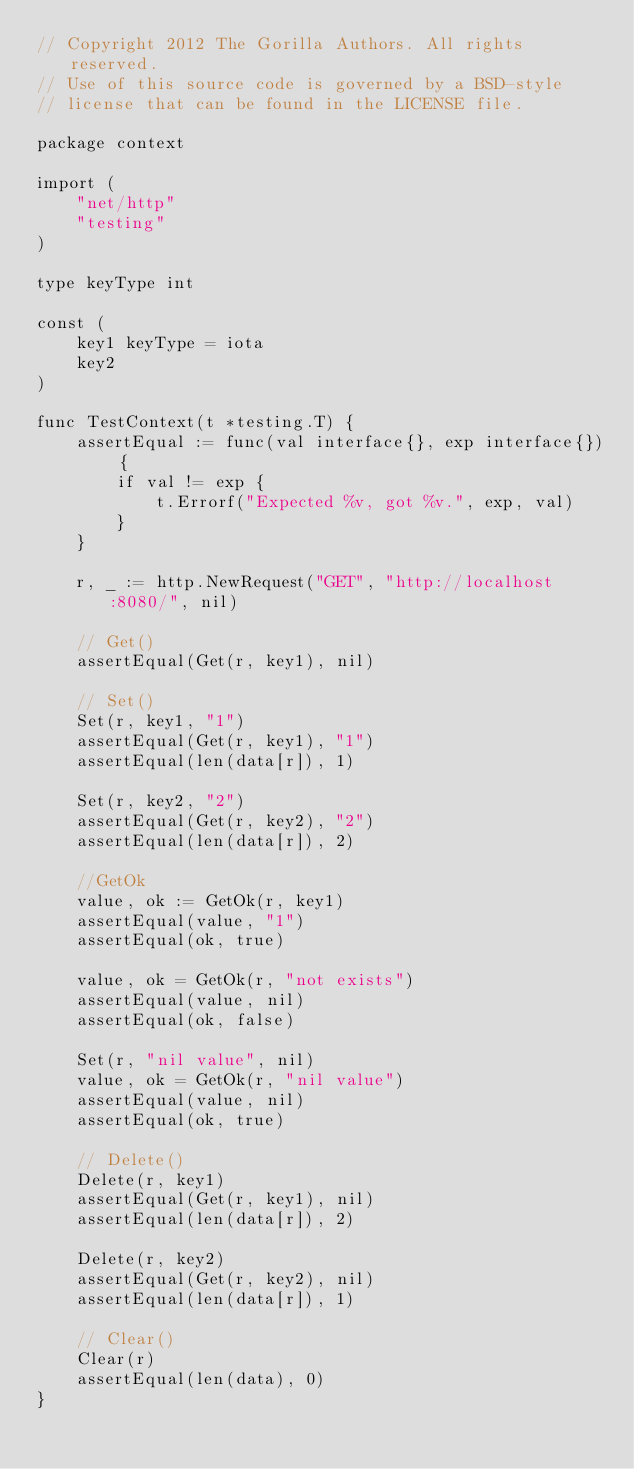<code> <loc_0><loc_0><loc_500><loc_500><_Go_>// Copyright 2012 The Gorilla Authors. All rights reserved.
// Use of this source code is governed by a BSD-style
// license that can be found in the LICENSE file.

package context

import (
	"net/http"
	"testing"
)

type keyType int

const (
	key1 keyType = iota
	key2
)

func TestContext(t *testing.T) {
	assertEqual := func(val interface{}, exp interface{}) {
		if val != exp {
			t.Errorf("Expected %v, got %v.", exp, val)
		}
	}

	r, _ := http.NewRequest("GET", "http://localhost:8080/", nil)

	// Get()
	assertEqual(Get(r, key1), nil)

	// Set()
	Set(r, key1, "1")
	assertEqual(Get(r, key1), "1")
	assertEqual(len(data[r]), 1)

	Set(r, key2, "2")
	assertEqual(Get(r, key2), "2")
	assertEqual(len(data[r]), 2)

	//GetOk
	value, ok := GetOk(r, key1)
	assertEqual(value, "1")
	assertEqual(ok, true)

	value, ok = GetOk(r, "not exists")
	assertEqual(value, nil)
	assertEqual(ok, false)

	Set(r, "nil value", nil)
	value, ok = GetOk(r, "nil value")
	assertEqual(value, nil)
	assertEqual(ok, true)

	// Delete()
	Delete(r, key1)
	assertEqual(Get(r, key1), nil)
	assertEqual(len(data[r]), 2)

	Delete(r, key2)
	assertEqual(Get(r, key2), nil)
	assertEqual(len(data[r]), 1)

	// Clear()
	Clear(r)
	assertEqual(len(data), 0)
}
</code> 